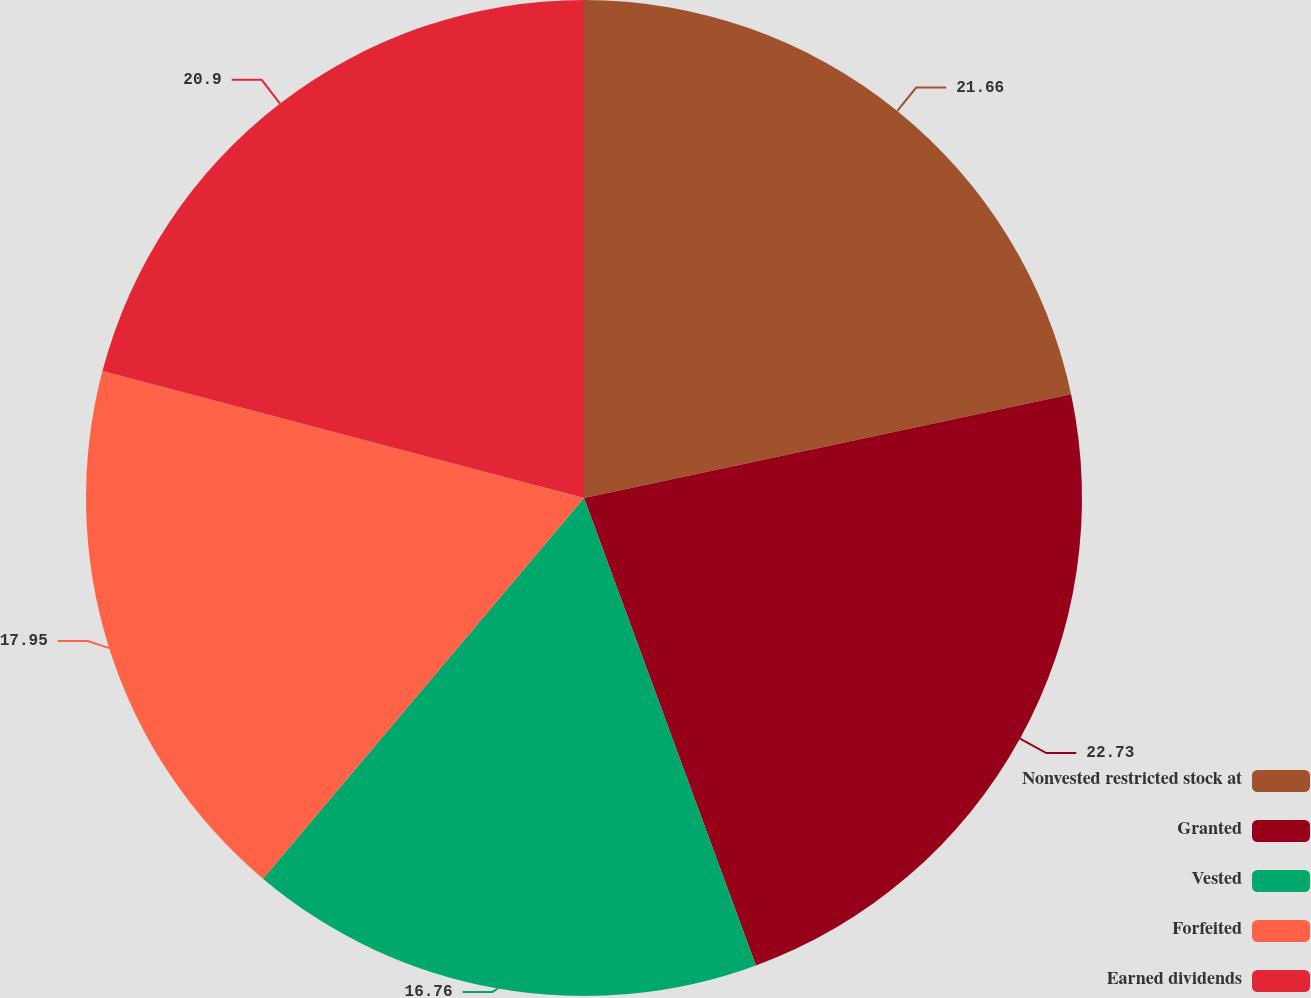Convert chart. <chart><loc_0><loc_0><loc_500><loc_500><pie_chart><fcel>Nonvested restricted stock at<fcel>Granted<fcel>Vested<fcel>Forfeited<fcel>Earned dividends<nl><fcel>21.66%<fcel>22.73%<fcel>16.76%<fcel>17.95%<fcel>20.9%<nl></chart> 